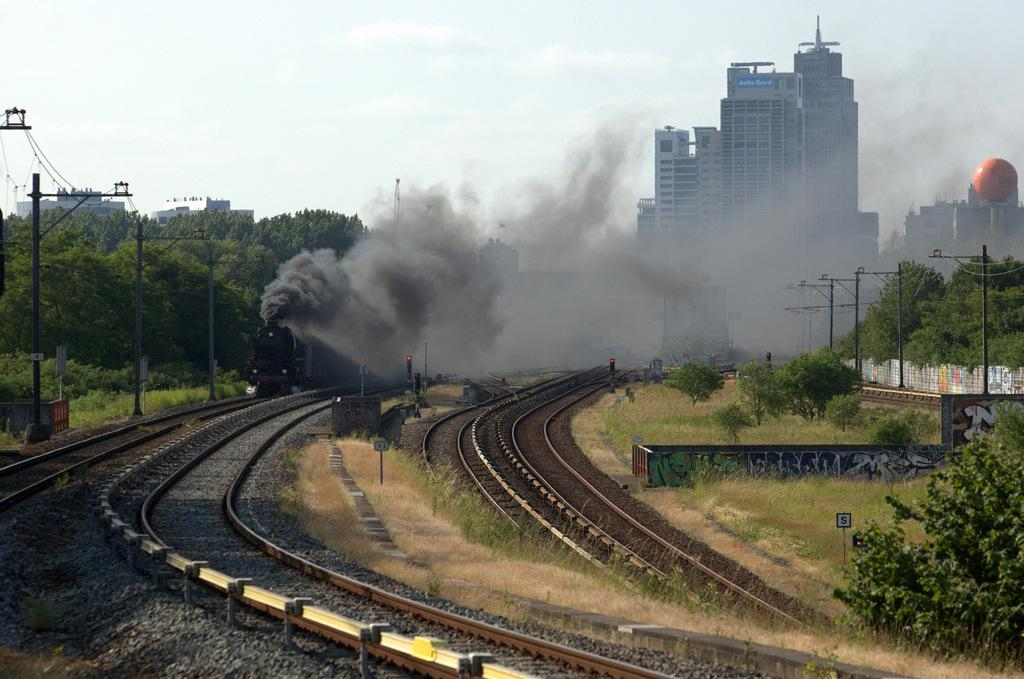What can be seen in the image that indicates the presence of a transportation system? There is a train and railway tracks visible in the image. What is the natural environment like in the image? There are trees in the image. What type of infrastructure is present in the image? Electricity poles are present in the image. What type of structures can be seen in the image? There are buildings and a tower visible in the image. What is the background of the image? The sky is visible in the image. How many kittens are playing with jelly on the tower in the image? There are no kittens or jelly present in the image; it features a train, railway tracks, trees, electricity poles, buildings, a wall, a tower, and the sky. What type of fish can be seen swimming in the smoke in the image? There are no fish present in the image, and the smoke is not a body of water where fish could swim. 